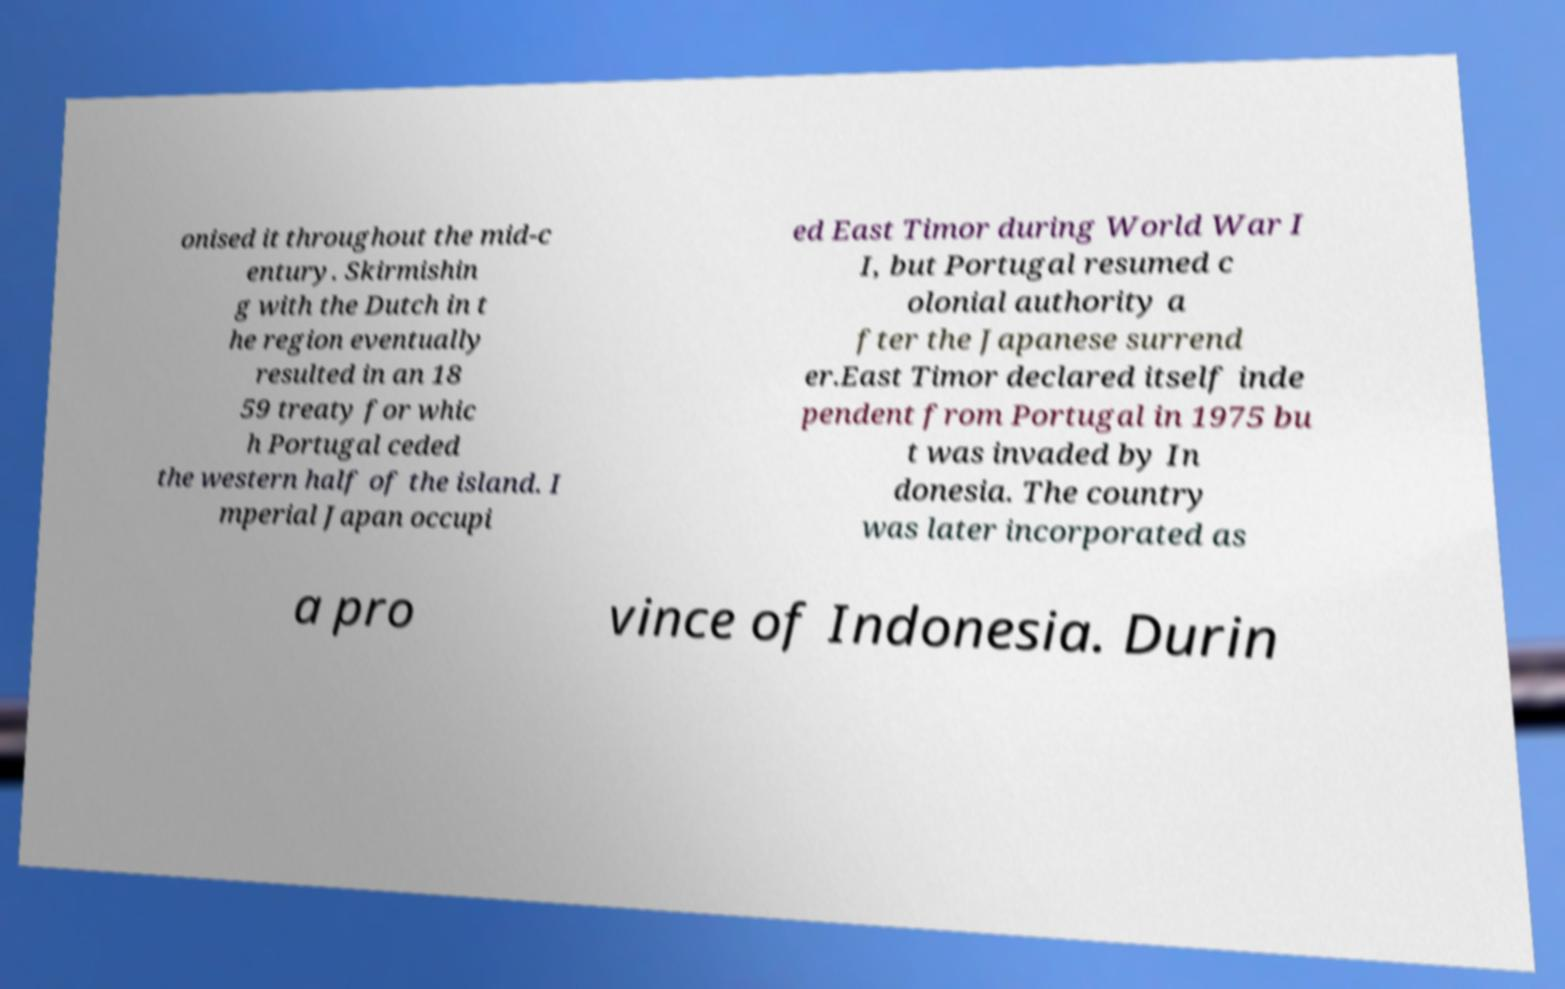For documentation purposes, I need the text within this image transcribed. Could you provide that? onised it throughout the mid-c entury. Skirmishin g with the Dutch in t he region eventually resulted in an 18 59 treaty for whic h Portugal ceded the western half of the island. I mperial Japan occupi ed East Timor during World War I I, but Portugal resumed c olonial authority a fter the Japanese surrend er.East Timor declared itself inde pendent from Portugal in 1975 bu t was invaded by In donesia. The country was later incorporated as a pro vince of Indonesia. Durin 